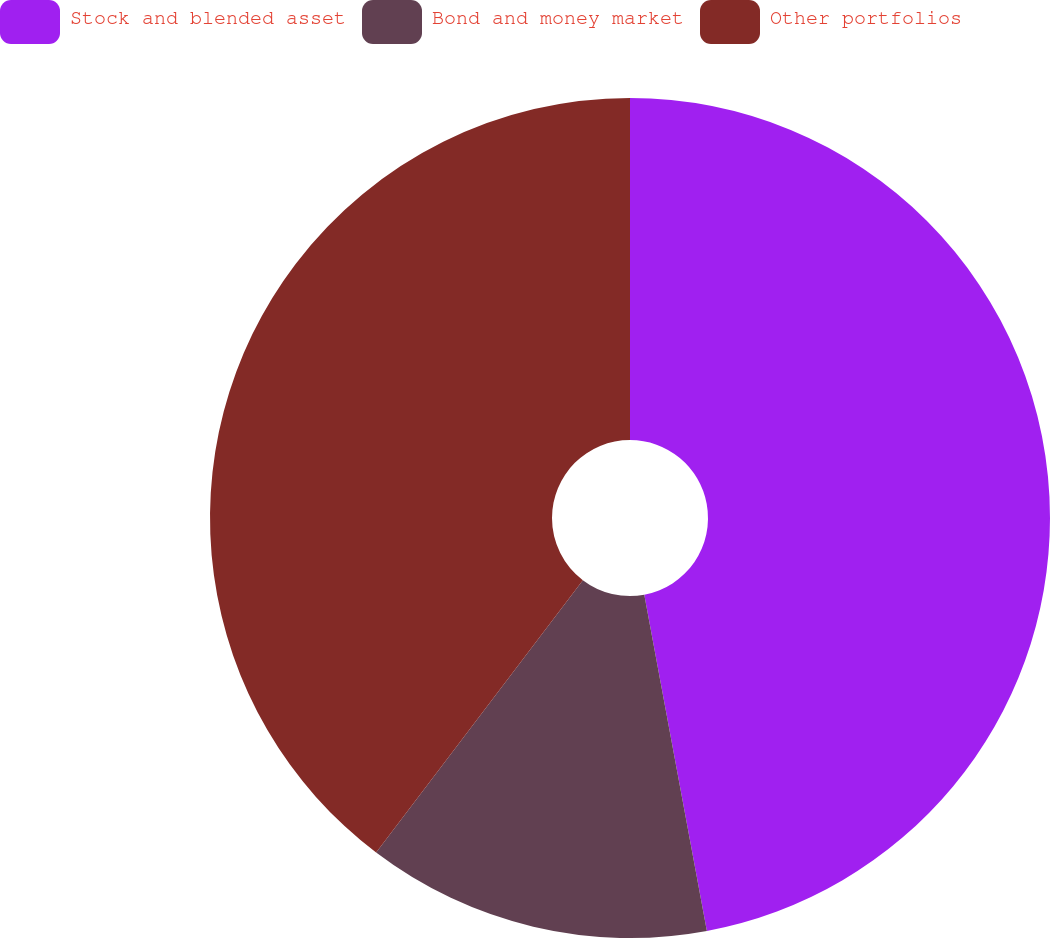Convert chart to OTSL. <chart><loc_0><loc_0><loc_500><loc_500><pie_chart><fcel>Stock and blended asset<fcel>Bond and money market<fcel>Other portfolios<nl><fcel>47.07%<fcel>13.26%<fcel>39.67%<nl></chart> 